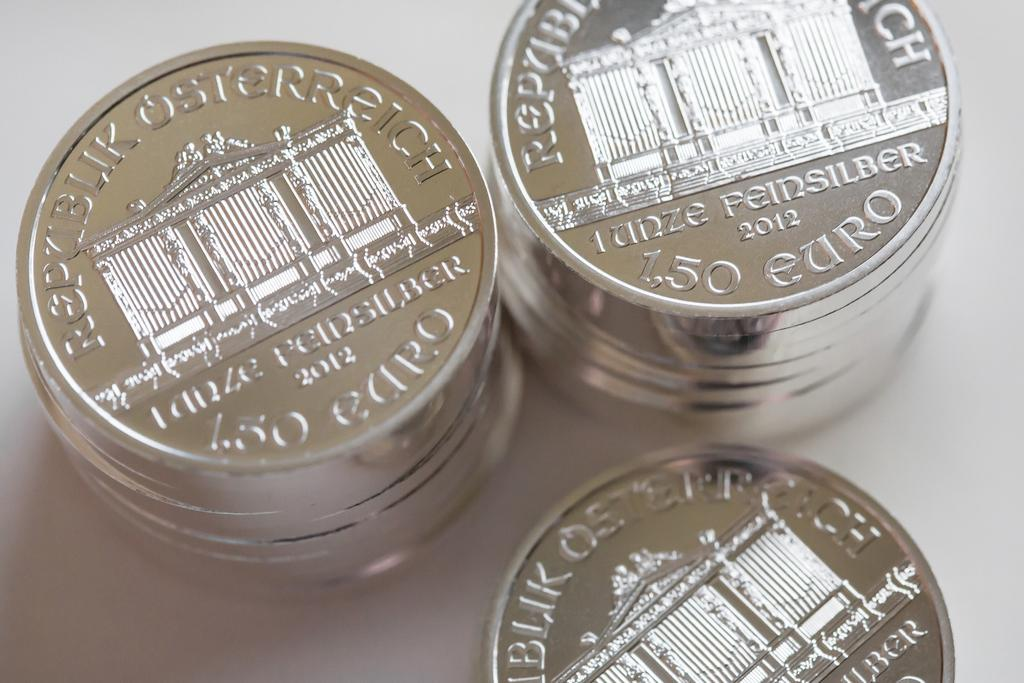<image>
Share a concise interpretation of the image provided. Three stacks of Euro coins are bright silver in color. 